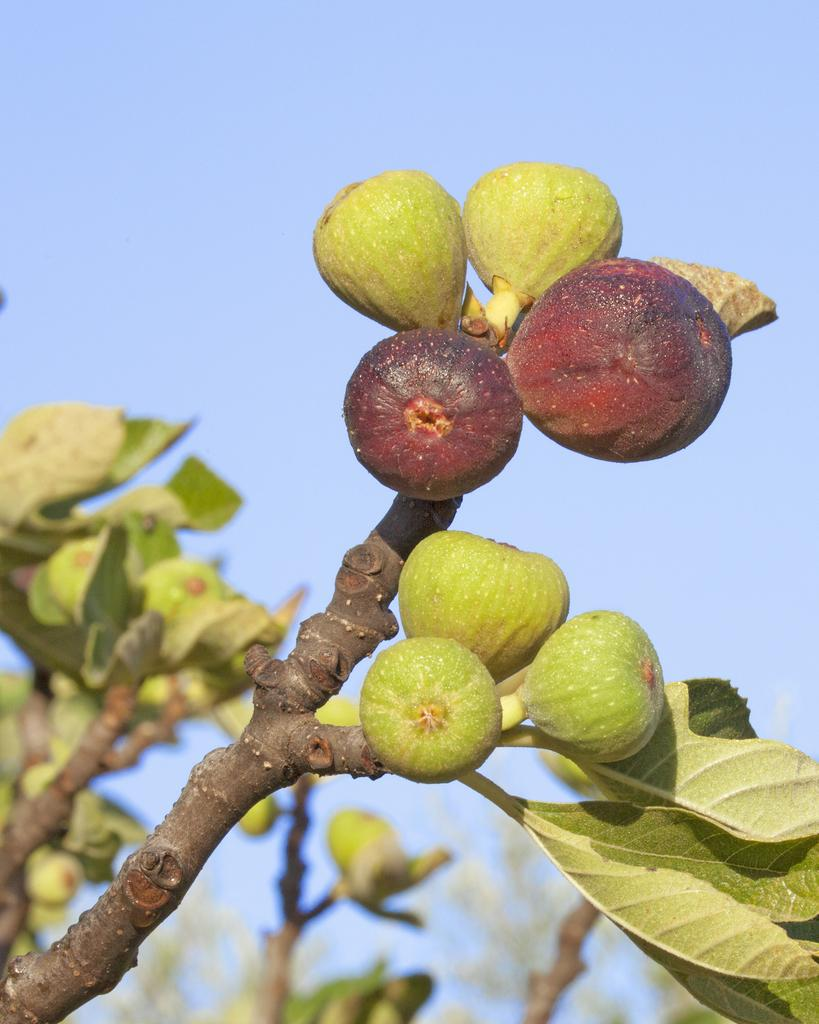What type of vegetation is present on the trees in the image? There are fruits on the trees in the image. What can be seen in the background of the image? The sky is visible in the background of the image. Where is the carriage located in the image? There is no carriage present in the image. What type of animal can be seen interacting with the fruits on the trees in the image? There are no animals present in the image; it only features fruits on the trees and the sky in the background. 